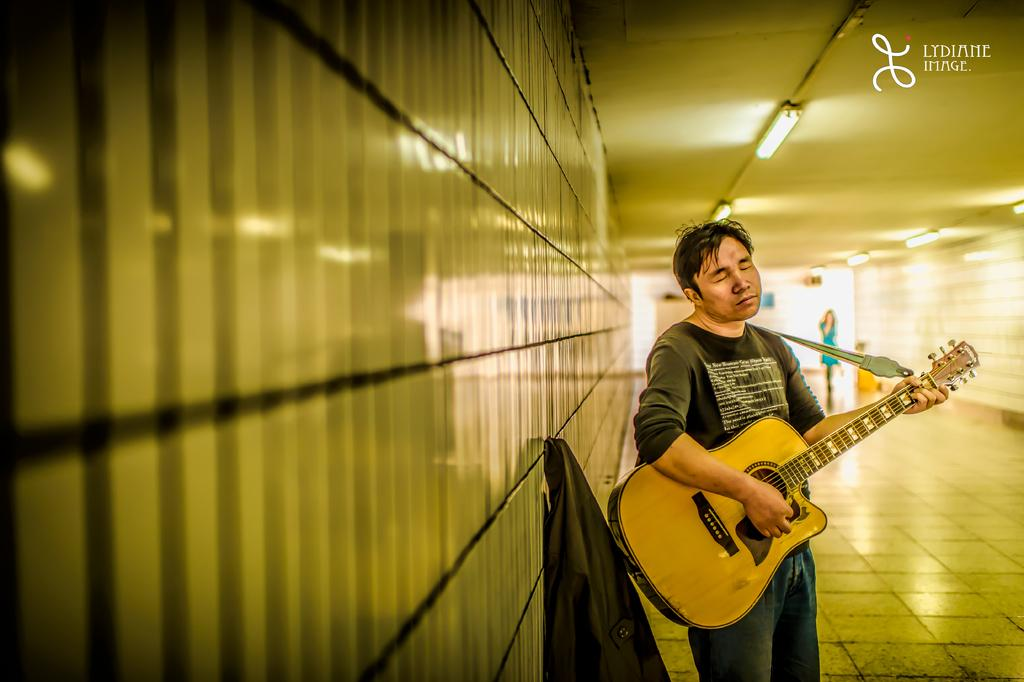What is the man in the image doing? The man is playing a guitar in the image. Who else is present in the image? There is a woman in the image. Can you describe the woman's position in relation to the man? The woman is standing behind the man in the image. What type of honey is the man using to play the guitar in the image? There is no honey present in the image, and it is not being used to play the guitar. How many chickens are visible in the image? There are no chickens present in the image. 